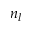Convert formula to latex. <formula><loc_0><loc_0><loc_500><loc_500>n _ { l }</formula> 